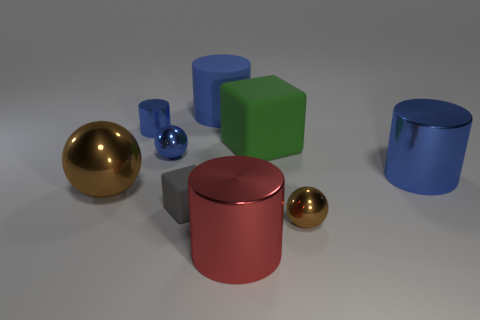There is a red metallic object that is on the right side of the small gray rubber object; does it have the same size as the brown sphere on the right side of the big red metallic cylinder?
Provide a short and direct response. No. What material is the small thing that is behind the small blue thing right of the small blue cylinder?
Your response must be concise. Metal. What number of things are blue objects to the right of the tiny brown sphere or blue objects?
Provide a short and direct response. 4. Is the number of big red metal objects behind the matte cylinder the same as the number of red metal cylinders behind the big green rubber object?
Provide a short and direct response. Yes. What material is the blue object on the right side of the big metal cylinder that is in front of the tiny brown metal object to the right of the red shiny cylinder?
Your answer should be compact. Metal. How big is the object that is on the left side of the blue sphere and behind the green rubber object?
Offer a very short reply. Small. Do the big red object and the green rubber object have the same shape?
Provide a succinct answer. No. What is the shape of the big blue object that is the same material as the red cylinder?
Ensure brevity in your answer.  Cylinder. How many big objects are gray metal objects or red metal things?
Offer a very short reply. 1. Is there a metal cylinder behind the brown object to the right of the blue metallic ball?
Provide a short and direct response. Yes. 